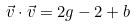<formula> <loc_0><loc_0><loc_500><loc_500>\vec { v } \cdot \vec { v } = 2 g - 2 + b</formula> 